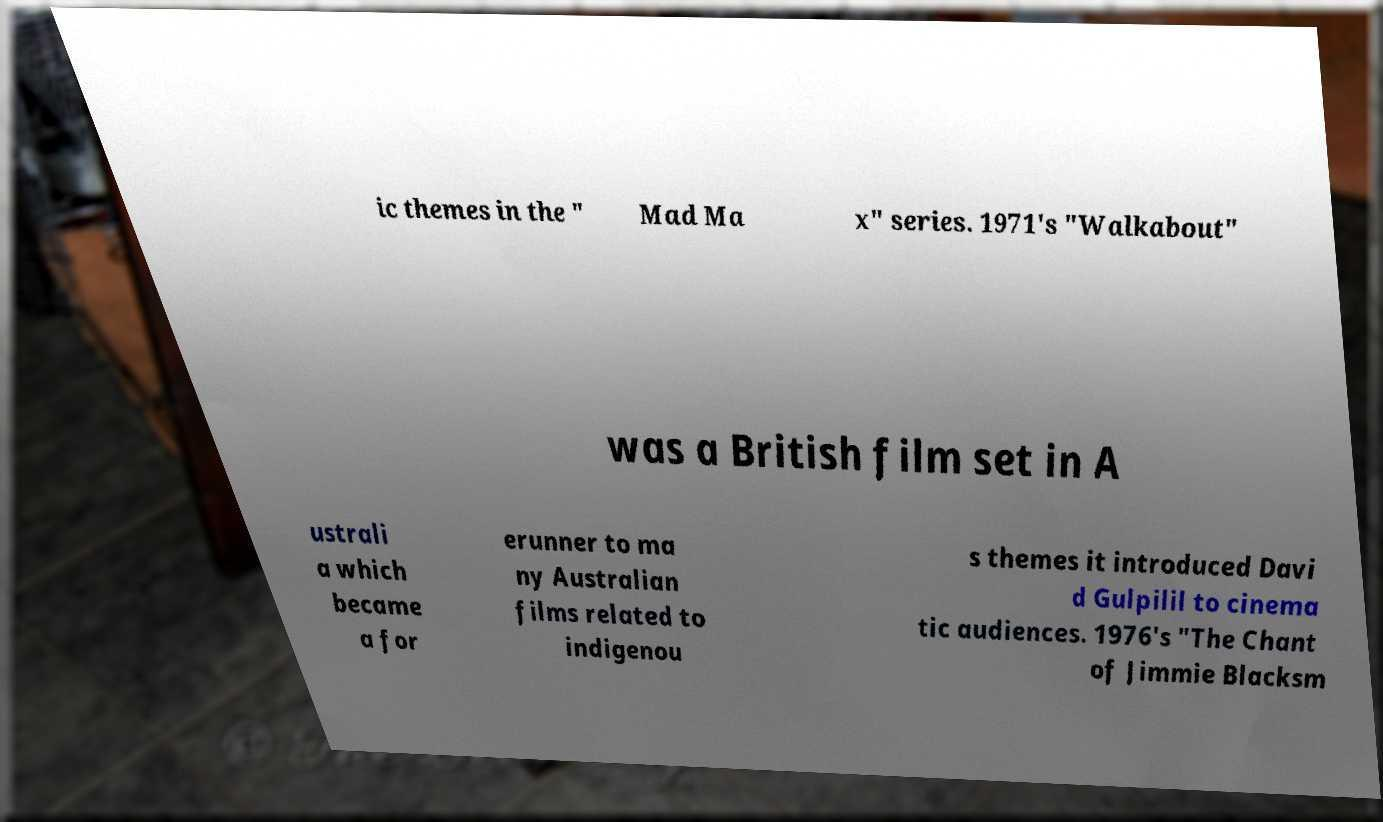For documentation purposes, I need the text within this image transcribed. Could you provide that? ic themes in the " Mad Ma x" series. 1971's "Walkabout" was a British film set in A ustrali a which became a for erunner to ma ny Australian films related to indigenou s themes it introduced Davi d Gulpilil to cinema tic audiences. 1976's "The Chant of Jimmie Blacksm 